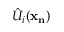<formula> <loc_0><loc_0><loc_500><loc_500>\hat { U } _ { i } ( x _ { n } )</formula> 